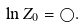<formula> <loc_0><loc_0><loc_500><loc_500>\ln Z _ { 0 } = \bigcirc .</formula> 